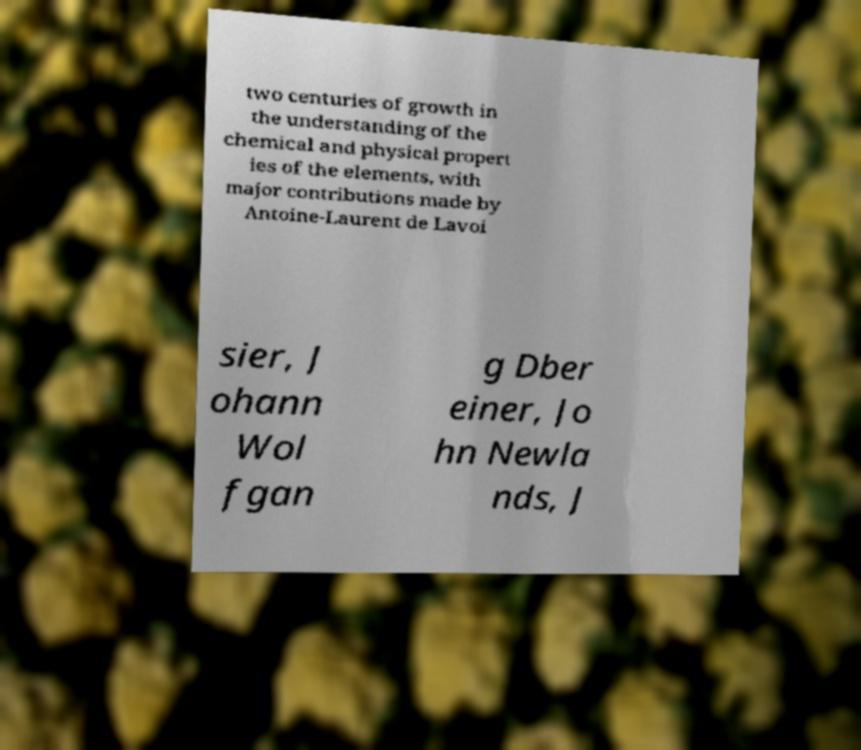Could you extract and type out the text from this image? two centuries of growth in the understanding of the chemical and physical propert ies of the elements, with major contributions made by Antoine-Laurent de Lavoi sier, J ohann Wol fgan g Dber einer, Jo hn Newla nds, J 